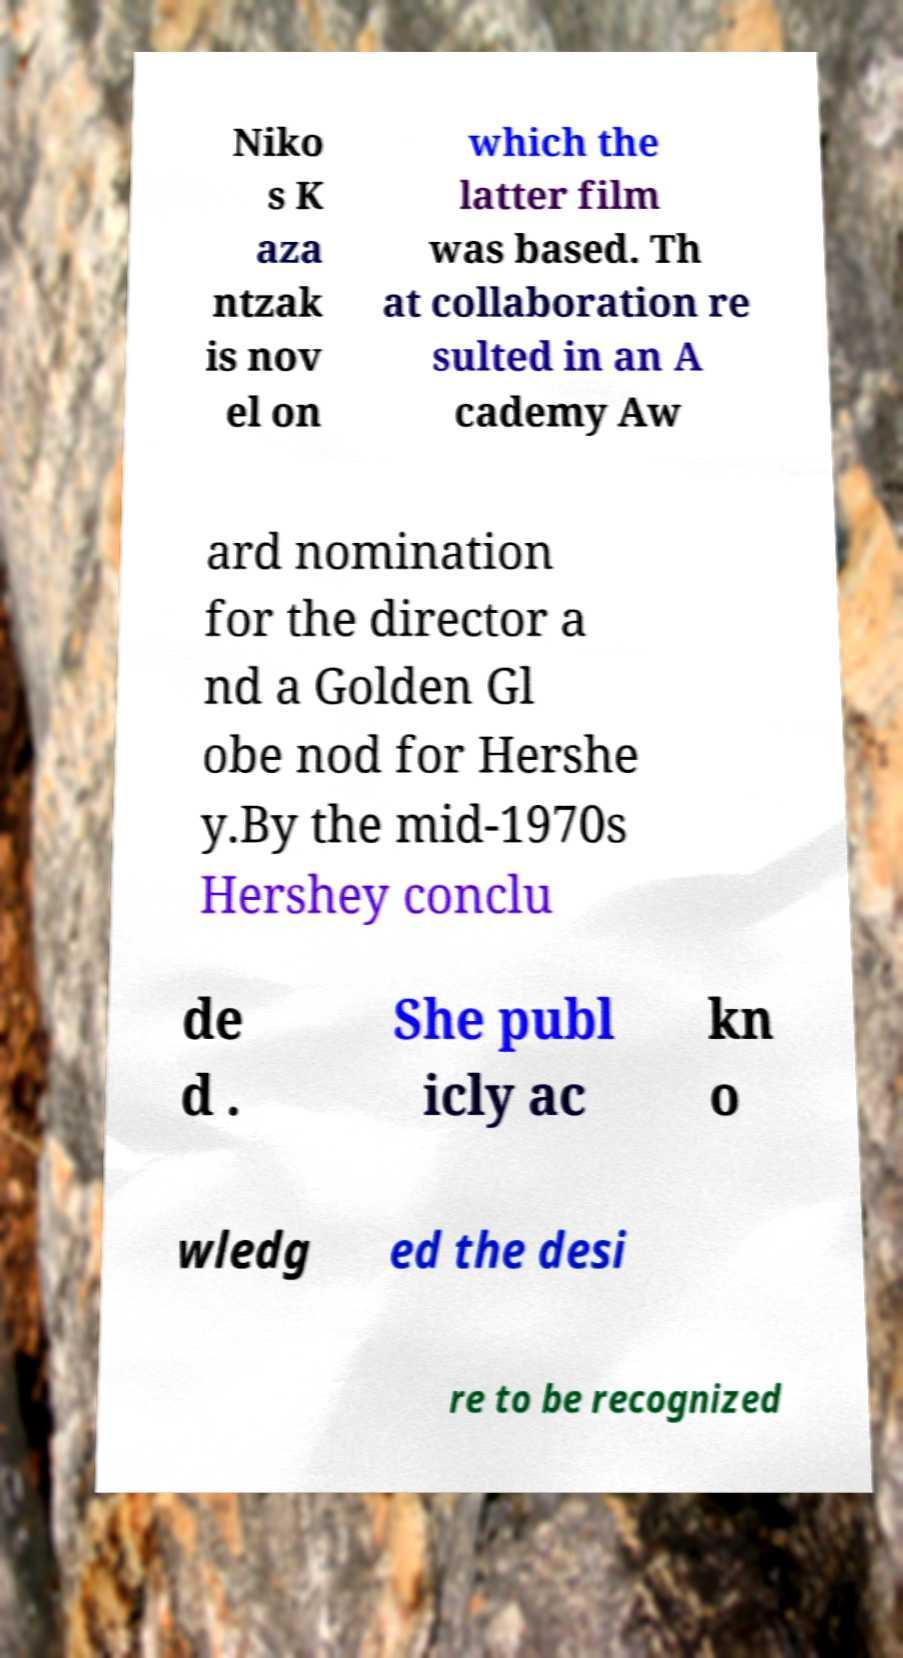For documentation purposes, I need the text within this image transcribed. Could you provide that? Niko s K aza ntzak is nov el on which the latter film was based. Th at collaboration re sulted in an A cademy Aw ard nomination for the director a nd a Golden Gl obe nod for Hershe y.By the mid-1970s Hershey conclu de d . She publ icly ac kn o wledg ed the desi re to be recognized 